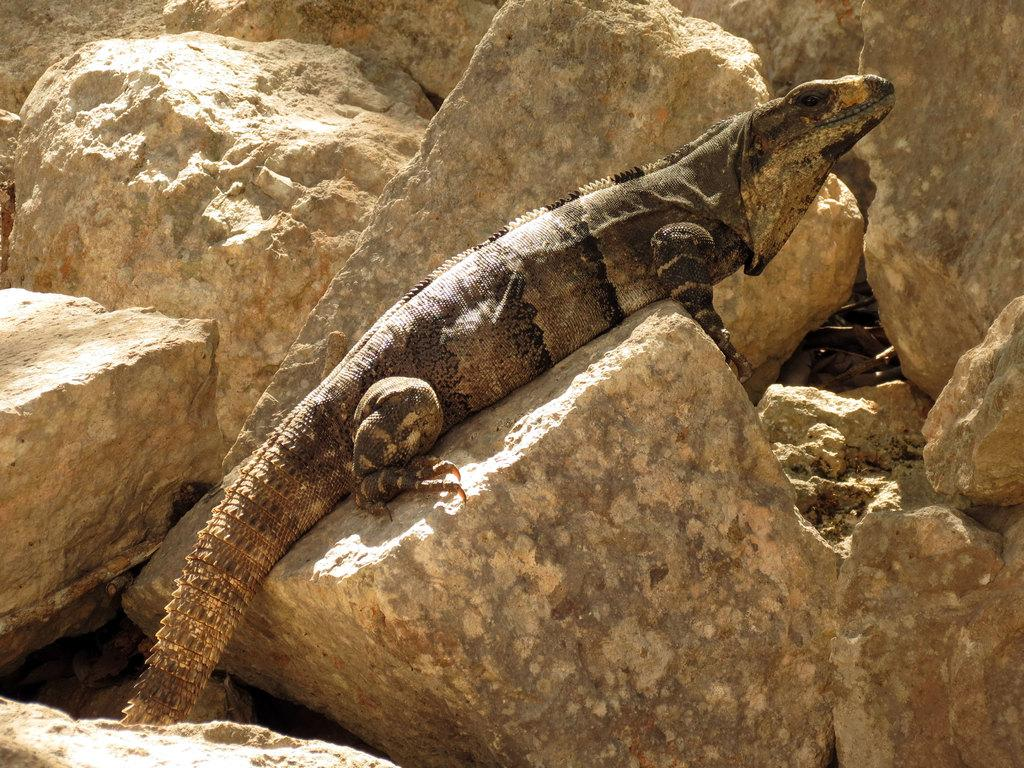What type of animal is in the image? There is a reptile in the image. Where is the reptile located? The reptile is on a rock. What else can be seen in the image besides the reptile? There are rocks around the reptile in the image. What historical event is depicted in the image? There is no historical event depicted in the image; it features a reptile on a rock with rocks surrounding it. What type of lamp is present in the image? There is no lamp present in the image. 